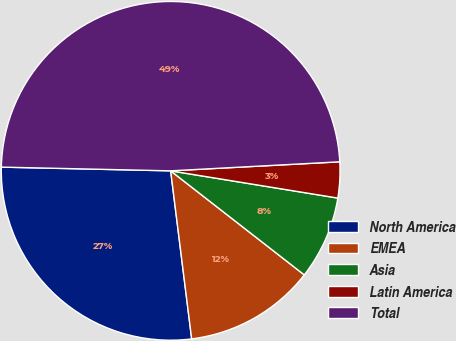Convert chart to OTSL. <chart><loc_0><loc_0><loc_500><loc_500><pie_chart><fcel>North America<fcel>EMEA<fcel>Asia<fcel>Latin America<fcel>Total<nl><fcel>27.33%<fcel>12.49%<fcel>7.96%<fcel>3.42%<fcel>48.8%<nl></chart> 